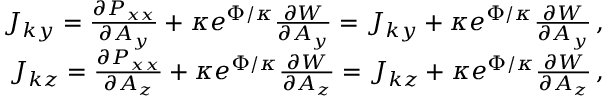<formula> <loc_0><loc_0><loc_500><loc_500>\begin{array} { r } { J _ { k y } = \frac { \partial P _ { x x } } { \partial A _ { y } } + \kappa e ^ { \Phi / \kappa } \frac { \partial W } { \partial A _ { y } } = J _ { k y } + \kappa e ^ { \Phi / \kappa } \frac { \partial W } { \partial A _ { y } } \, , } \\ { J _ { k z } = \frac { \partial P _ { x x } } { \partial A _ { z } } + \kappa e ^ { \Phi / \kappa } \frac { \partial W } { \partial A _ { z } } = J _ { k z } + \kappa e ^ { \Phi / \kappa } \frac { \partial W } { \partial A _ { z } } \, , } \end{array}</formula> 